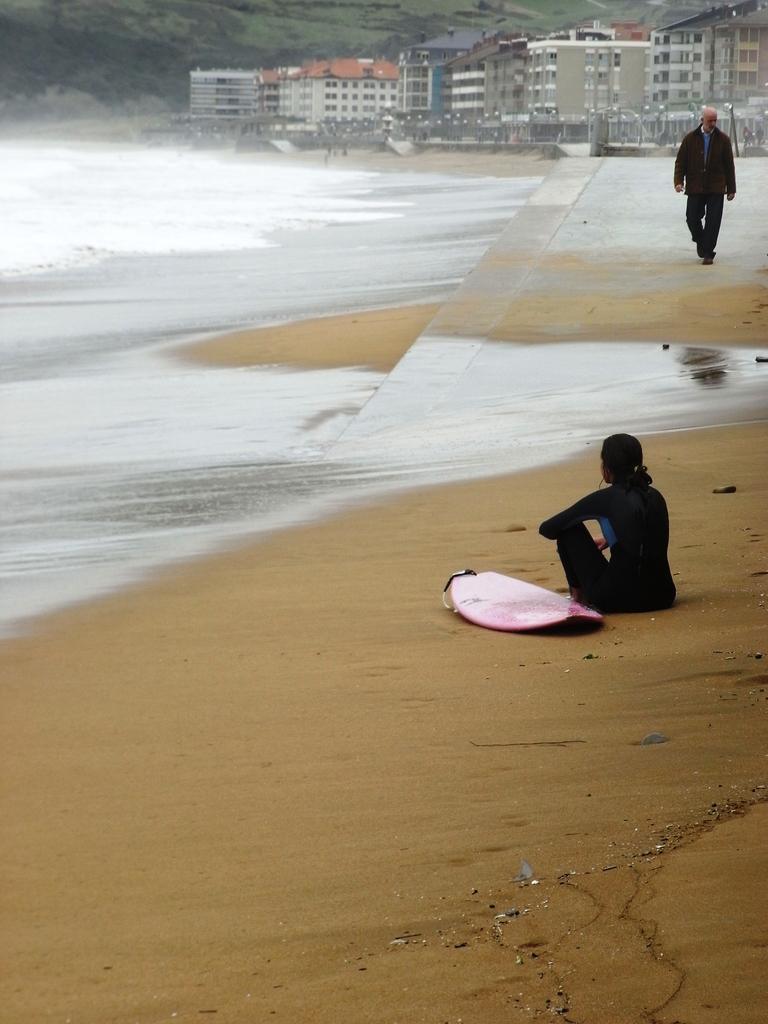Can you describe this image briefly? In this image I can see two persons on the beach. In the background I can see water, fence, buildings, trees and mountains. This image is taken near the sandy beach. 